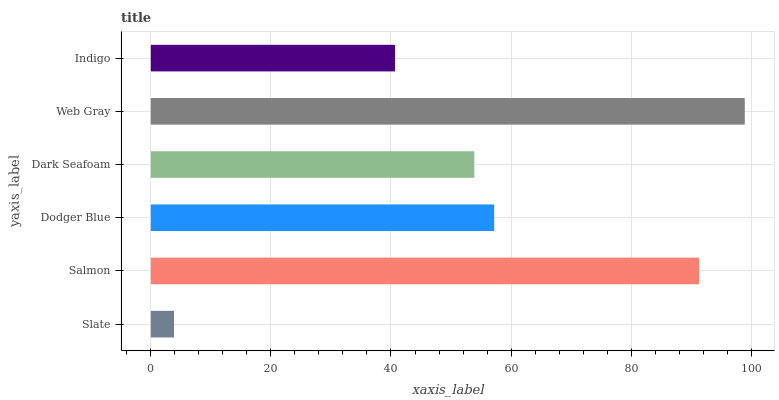Is Slate the minimum?
Answer yes or no. Yes. Is Web Gray the maximum?
Answer yes or no. Yes. Is Salmon the minimum?
Answer yes or no. No. Is Salmon the maximum?
Answer yes or no. No. Is Salmon greater than Slate?
Answer yes or no. Yes. Is Slate less than Salmon?
Answer yes or no. Yes. Is Slate greater than Salmon?
Answer yes or no. No. Is Salmon less than Slate?
Answer yes or no. No. Is Dodger Blue the high median?
Answer yes or no. Yes. Is Dark Seafoam the low median?
Answer yes or no. Yes. Is Indigo the high median?
Answer yes or no. No. Is Web Gray the low median?
Answer yes or no. No. 